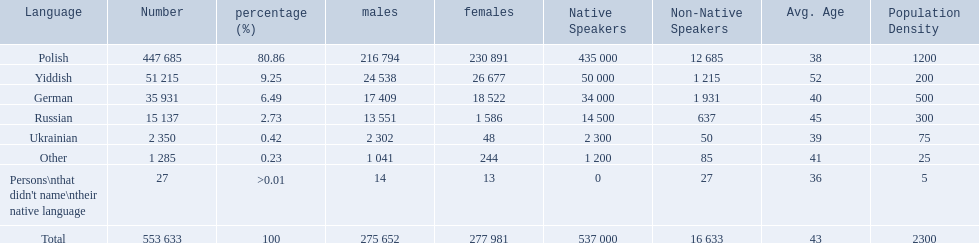Which language options are listed? Polish, Yiddish, German, Russian, Ukrainian, Other, Persons\nthat didn't name\ntheir native language. Of these, which did .42% of the people select? Ukrainian. 